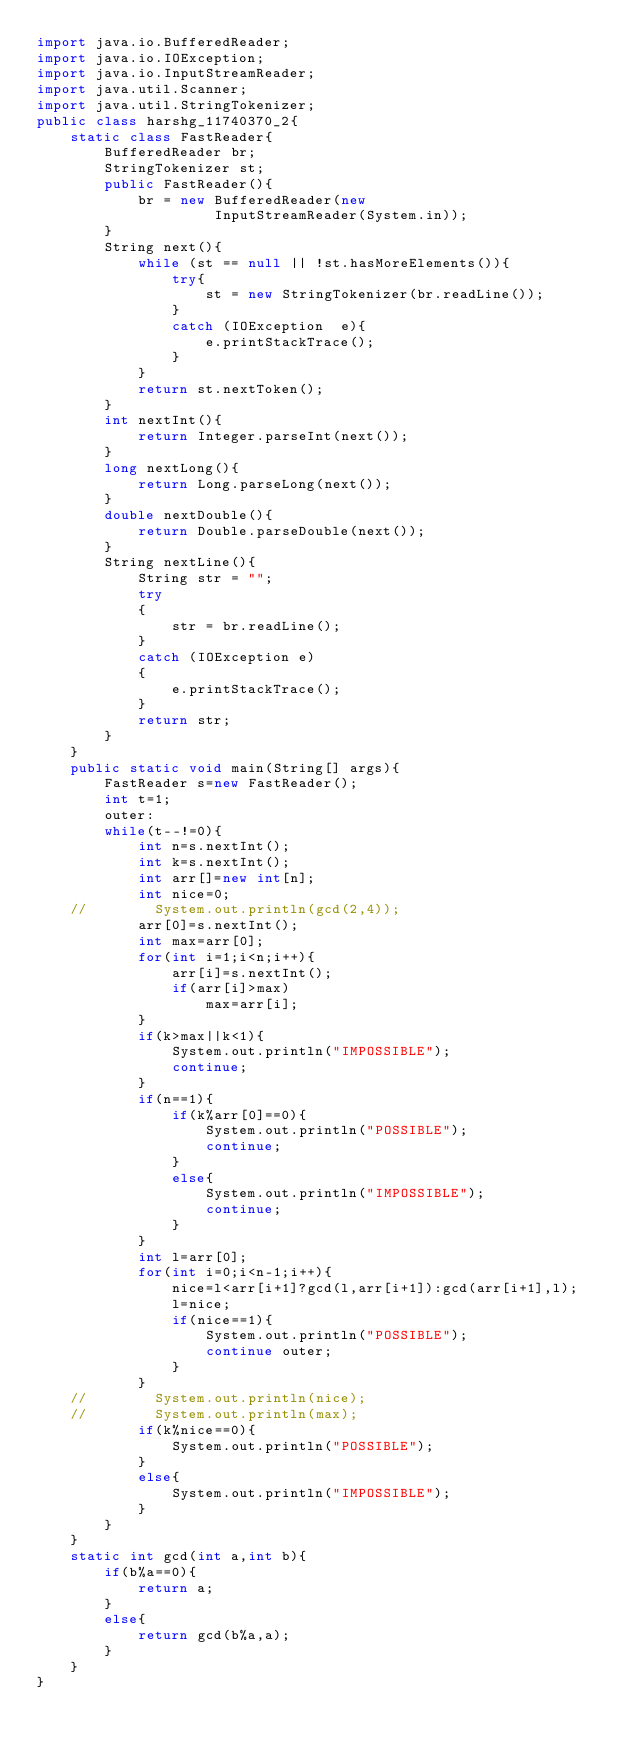<code> <loc_0><loc_0><loc_500><loc_500><_Java_>import java.io.BufferedReader;
import java.io.IOException;
import java.io.InputStreamReader;
import java.util.Scanner;
import java.util.StringTokenizer;
public class harshg_11740370_2{
    static class FastReader{
        BufferedReader br;
        StringTokenizer st;
        public FastReader(){
            br = new BufferedReader(new
                     InputStreamReader(System.in));
        }
        String next(){
            while (st == null || !st.hasMoreElements()){
                try{
                    st = new StringTokenizer(br.readLine());
                }
                catch (IOException  e){
                    e.printStackTrace();
                }
            }
            return st.nextToken();
        }
        int nextInt(){
            return Integer.parseInt(next());
        }
        long nextLong(){
            return Long.parseLong(next());
        }
        double nextDouble(){
            return Double.parseDouble(next());
        }
        String nextLine(){
            String str = "";
            try
            {
                str = br.readLine();
            }
            catch (IOException e)
            {
                e.printStackTrace();
            }
            return str;
        }
    }
    public static void main(String[] args){
        FastReader s=new FastReader();
        int t=1;
        outer:
        while(t--!=0){
            int n=s.nextInt();
            int k=s.nextInt();
            int arr[]=new int[n];
            int nice=0;
    //        System.out.println(gcd(2,4));
            arr[0]=s.nextInt();
            int max=arr[0];
            for(int i=1;i<n;i++){
                arr[i]=s.nextInt();
                if(arr[i]>max)
                    max=arr[i];
            }
            if(k>max||k<1){
                System.out.println("IMPOSSIBLE");
                continue;
            }
            if(n==1){
                if(k%arr[0]==0){
                    System.out.println("POSSIBLE");
                    continue;
                }
                else{
                    System.out.println("IMPOSSIBLE");
                    continue;
                }
            }       
            int l=arr[0];
            for(int i=0;i<n-1;i++){
                nice=l<arr[i+1]?gcd(l,arr[i+1]):gcd(arr[i+1],l);
                l=nice;
                if(nice==1){
                    System.out.println("POSSIBLE");
                    continue outer;
                }
            }
    //        System.out.println(nice);
    //        System.out.println(max);
            if(k%nice==0){
                System.out.println("POSSIBLE");
            }
            else{
                System.out.println("IMPOSSIBLE");   
            }
        }
    }
    static int gcd(int a,int b){
        if(b%a==0){
            return a;
        }
        else{
            return gcd(b%a,a);
        }
    }
}</code> 